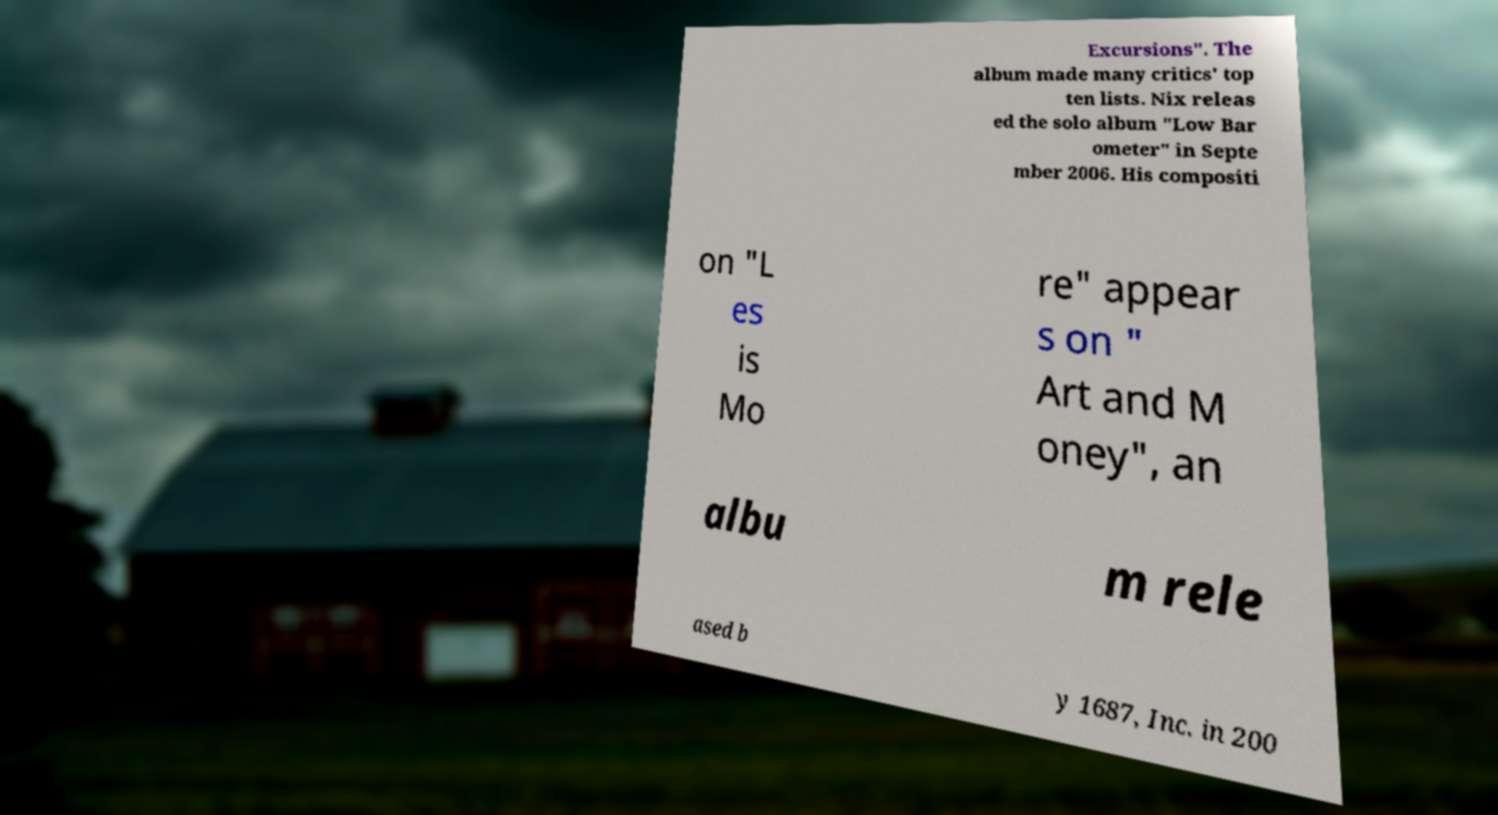Please read and relay the text visible in this image. What does it say? Excursions". The album made many critics' top ten lists. Nix releas ed the solo album "Low Bar ometer" in Septe mber 2006. His compositi on "L es is Mo re" appear s on " Art and M oney", an albu m rele ased b y 1687, Inc. in 200 